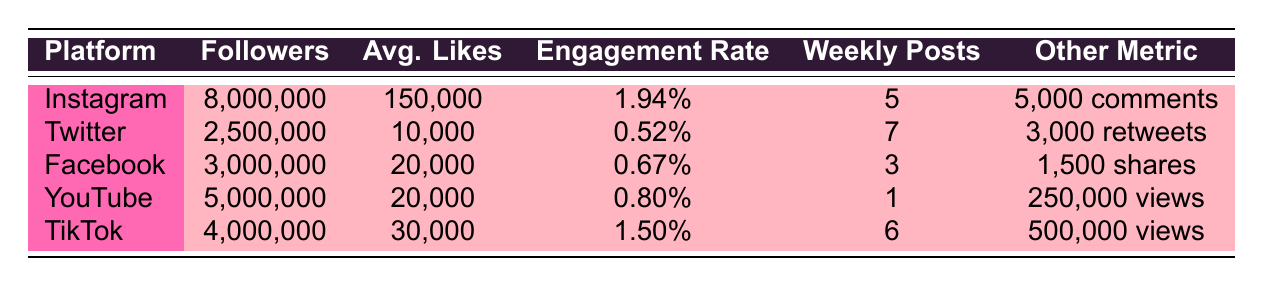What is the engagement rate on Instagram? The engagement rate provided in the table for Instagram is specifically listed as 1.94%.
Answer: 1.94% How many average likes does TikTok receive per post? According to the table, TikTok has an average of 30,000 likes per post.
Answer: 30,000 Which platform has the highest number of followers? By looking at the follower counts, Instagram has 8,000,000 followers, which is the highest among all platforms listed.
Answer: Instagram What is the total number of followers across all platforms? To find the total, we sum the followers from each platform: 8,000,000 (Instagram) + 2,500,000 (Twitter) + 3,000,000 (Facebook) + 5,000,000 (YouTube) + 4,000,000 (TikTok) = 22,500,000.
Answer: 22,500,000 Is TikTok's engagement rate higher than YouTube's engagement rate? TikTok has an engagement rate of 1.50%, while YouTube's engagement rate is 0.80%. Since 1.50% > 0.80%, TikTok's is indeed higher.
Answer: Yes What is the average number of likes for posts across all platforms? We calculate the averages based on the data provided: (150,000 + 10,000 + 20,000 + 20,000 + 30,000) / 5 = 46,000 / 5 = 9,200. So, the average number of likes across platforms is 9,200.
Answer: 46,000 What is the weekly post frequency for Facebook? The weekly post frequency for Facebook as listed in the table is 3 posts.
Answer: 3 Which platform has the lowest engagement rate? The engagement rates for the platforms are as follows: Instagram at 1.94%, TikTok at 1.50%, YouTube at 0.80%, Facebook at 0.67%, and Twitter at 0.52%. The lowest is 0.52% for Twitter.
Answer: Twitter How do the average likes on Facebook compare to that of Twitter? Facebook has an average of 20,000 likes per post while Twitter has 10,000 likes per post. Since 20,000 > 10,000, Facebook has more average likes than Twitter.
Answer: Yes 